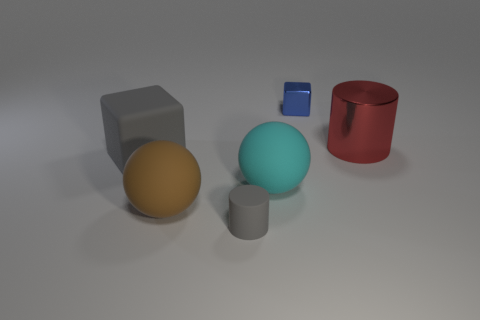Are there any other things that are the same color as the big block?
Offer a very short reply. Yes. What shape is the thing that is both right of the tiny cylinder and to the left of the tiny blue cube?
Make the answer very short. Sphere. What is the size of the block that is in front of the red cylinder?
Ensure brevity in your answer.  Large. There is a big matte ball that is left of the small object in front of the blue metallic cube; how many tiny things are behind it?
Your answer should be very brief. 1. There is a big cyan ball; are there any big matte cubes behind it?
Provide a succinct answer. Yes. How many other objects are the same size as the blue object?
Make the answer very short. 1. What material is the large object that is both behind the cyan thing and to the right of the large gray matte object?
Provide a short and direct response. Metal. Do the big rubber object behind the cyan matte sphere and the matte thing that is to the right of the small gray matte cylinder have the same shape?
Keep it short and to the point. No. Are there any other things that are the same material as the blue cube?
Give a very brief answer. Yes. What shape is the tiny object behind the block in front of the metallic thing to the right of the tiny shiny thing?
Keep it short and to the point. Cube. 